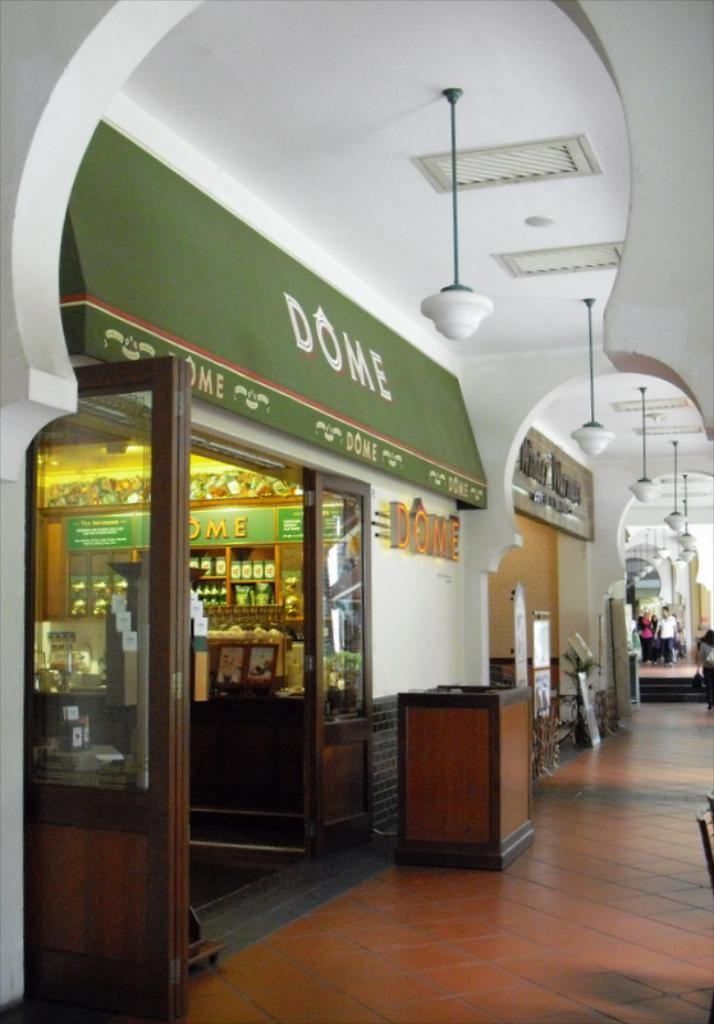What is the name of the store?
Your response must be concise. Dome. 